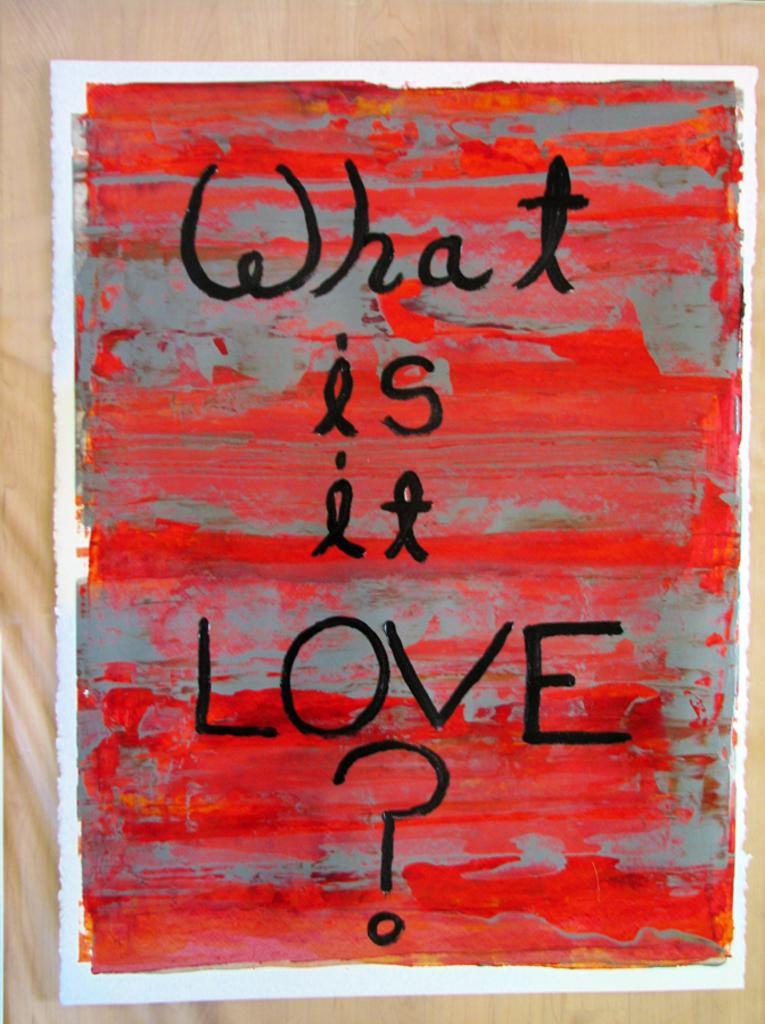<image>
Write a terse but informative summary of the picture. A painting with a red and grey background that says What is it Love? on it. 